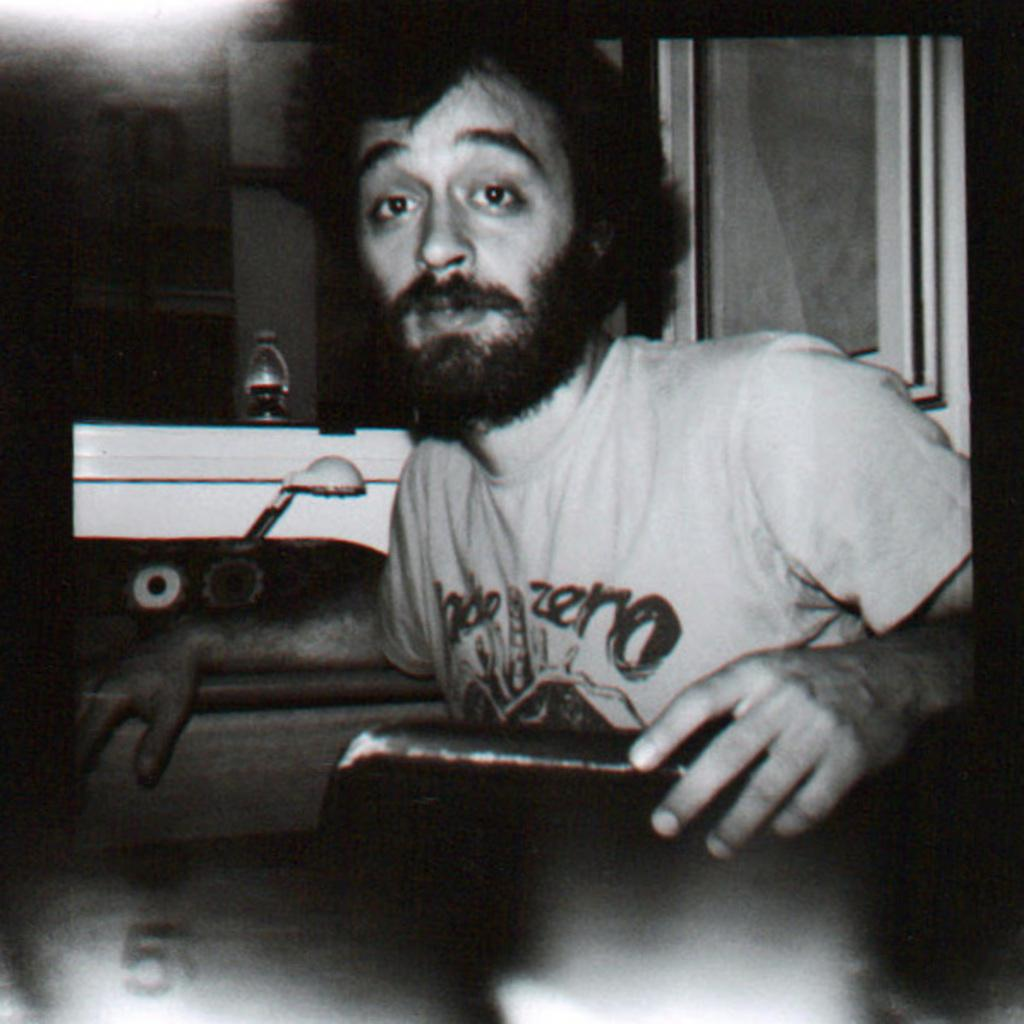What is the main subject in the foreground of the image? There is a man in the foreground of the image. What is the man doing in the image? The man is sitting in the image. What object is the man holding in the image? The man is holding a book in the image. What can be seen in the background of the image? There is a light wall and a window in the background of the image. How many beds can be seen in the image? There are no beds present in the image. What type of quiver is the man using to hold the book in the image? The man is not using a quiver to hold the book in the image; he is simply holding it with his hands. 